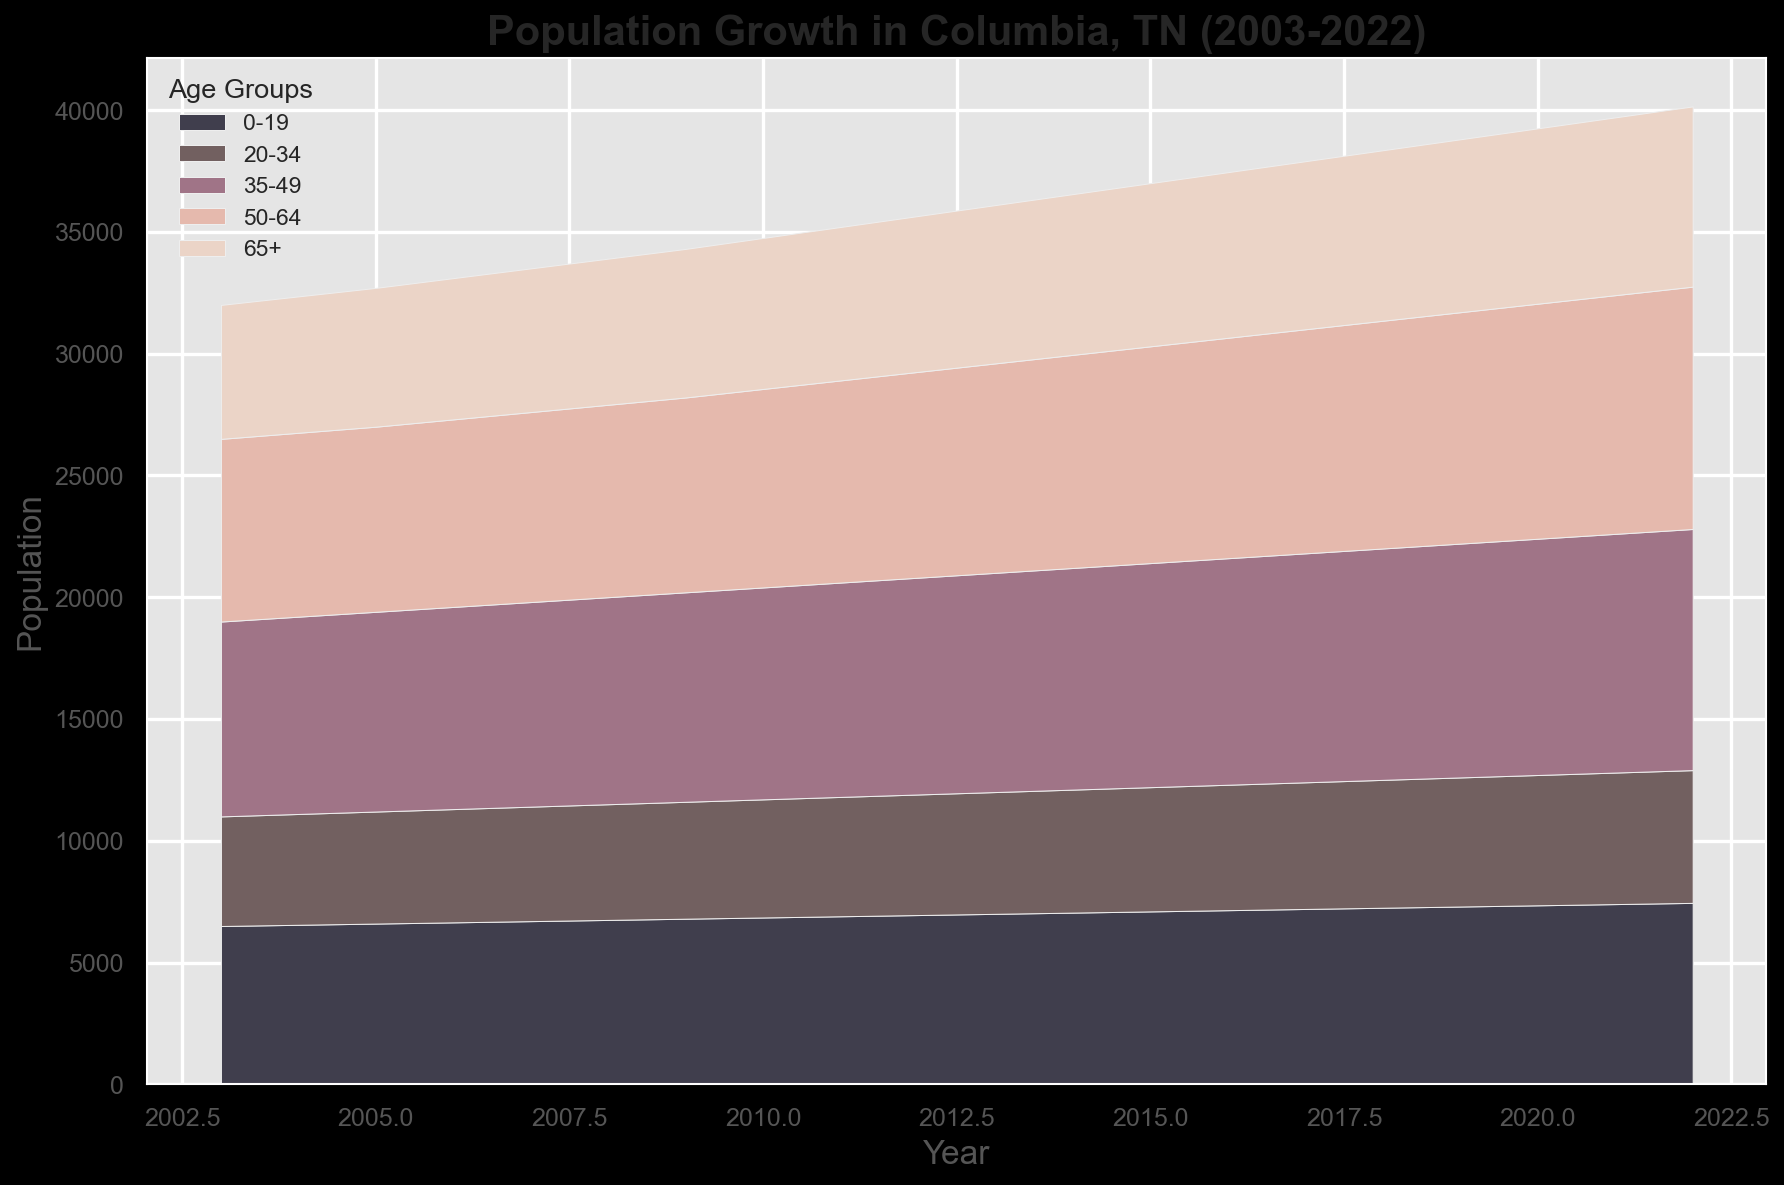What is the total population in 2022? To find the total population in 2022, add the populations of all age groups: 7450 (0-19) + 5450 (20-34) + 9900 (35-49) + 9950 (50-64) + 7400 (65+). This equals 40150.
Answer: 40150 How did the population of the 0-19 age group change over the years visually? The population of the 0-19 age group is represented by the section at the bottom of the area chart. Visually, it steadily increased from 6500 in 2003 to 7450 in 2022.
Answer: Steady increase In what year did the 65+ age group surpass a population of 6000? By observing the height section related to the 65+ age group, the population surpasses 6000 in 2008.
Answer: 2008 Compare the population of the 20-34 age group to the 35-49 age group in 2020. Which is higher? In the year 2020, the population of the 20-34 age group is 5350 and the 35-49 age group is 9700. By comparing these values, the 35-49 group is higher.
Answer: 35-49 What was the combined population of the 35-49 and 50-64 age groups in 2010? Sum the populations of the 35-49 and 50-64 age groups in 2010: 8700 (35-49) + 8150 (50-64) = 16850.
Answer: 16850 Identify the age group with the least population growth from 2003 to 2022. From the calculation of the population difference from 2003 to 2022: 
(0-19: 7450 - 6500 = 950), 
(20-34: 5450 - 4500 = 950), 
(35-49: 9900 - 8000 = 1900), 
(50-64: 9950 - 7500 = 2450), 
(65+: 7400 - 5500 = 1900). 
The groups 0-19 and 20-34 have the least population growth of 950.
Answer: 0-19, 20-34 